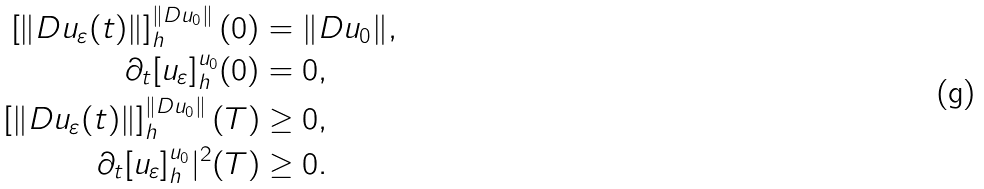Convert formula to latex. <formula><loc_0><loc_0><loc_500><loc_500>\left [ \| D u _ { \varepsilon } ( t ) \| \right ] _ { h } ^ { \| D u _ { 0 } \| } ( 0 ) & = \| D u _ { 0 } \| , \\ \partial _ { t } [ u _ { \varepsilon } ] _ { h } ^ { u _ { 0 } } ( 0 ) & = 0 , \\ \left [ \| D u _ { \varepsilon } ( t ) \| \right ] _ { h } ^ { \| D u _ { 0 } \| } ( T ) & \geq 0 , \\ \partial _ { t } [ u _ { \varepsilon } ] _ { h } ^ { u _ { 0 } } | ^ { 2 } ( T ) & \geq 0 .</formula> 